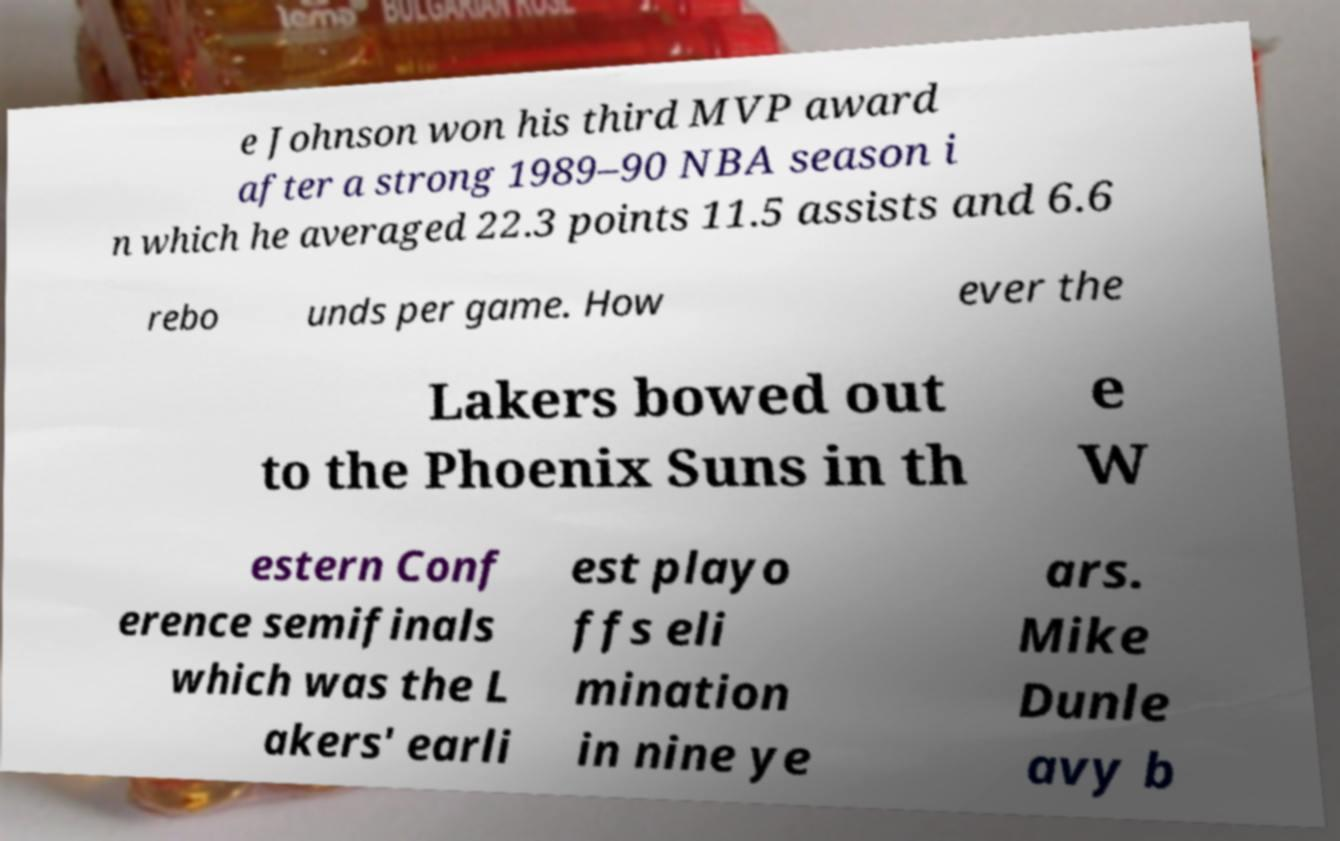Can you accurately transcribe the text from the provided image for me? e Johnson won his third MVP award after a strong 1989–90 NBA season i n which he averaged 22.3 points 11.5 assists and 6.6 rebo unds per game. How ever the Lakers bowed out to the Phoenix Suns in th e W estern Conf erence semifinals which was the L akers' earli est playo ffs eli mination in nine ye ars. Mike Dunle avy b 